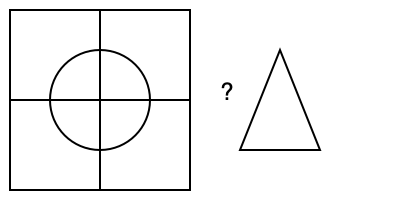A square piece of paper is folded in half vertically and horizontally, then a circle is cut out from the center. When unfolded, which shape represents the cutout in the paper? To visualize the folded shape of the paper cutout, let's follow these steps:

1. The square paper is folded in half vertically and horizontally, creating four equal quadrants.

2. A circle is cut out from the center, which means it affects all four quadrants equally.

3. When unfolded, the circular cutout will be mirrored across both the vertical and horizontal fold lines.

4. This mirroring effect creates a symmetrical shape in all four quadrants.

5. The resulting shape will have four identical "lobes" extending from the center, one in each quadrant.

6. These lobes form a cross-like shape, reminiscent of a four-petaled flower.

7. In Christian symbolism, this shape is known as a "Greek cross" or "equal-armed cross," where all four arms are of equal length.

8. The Greek cross is a significant symbol in Catholicism, representing the four equal parts of the world united by the central point of Christ's sacrifice.

Given the options in the diagram, the triangle does not match this description. The correct shape would be a cross with four equal arms extending from the center, symbolizing the unfolded circular cutout.
Answer: Greek cross (equal-armed cross) 